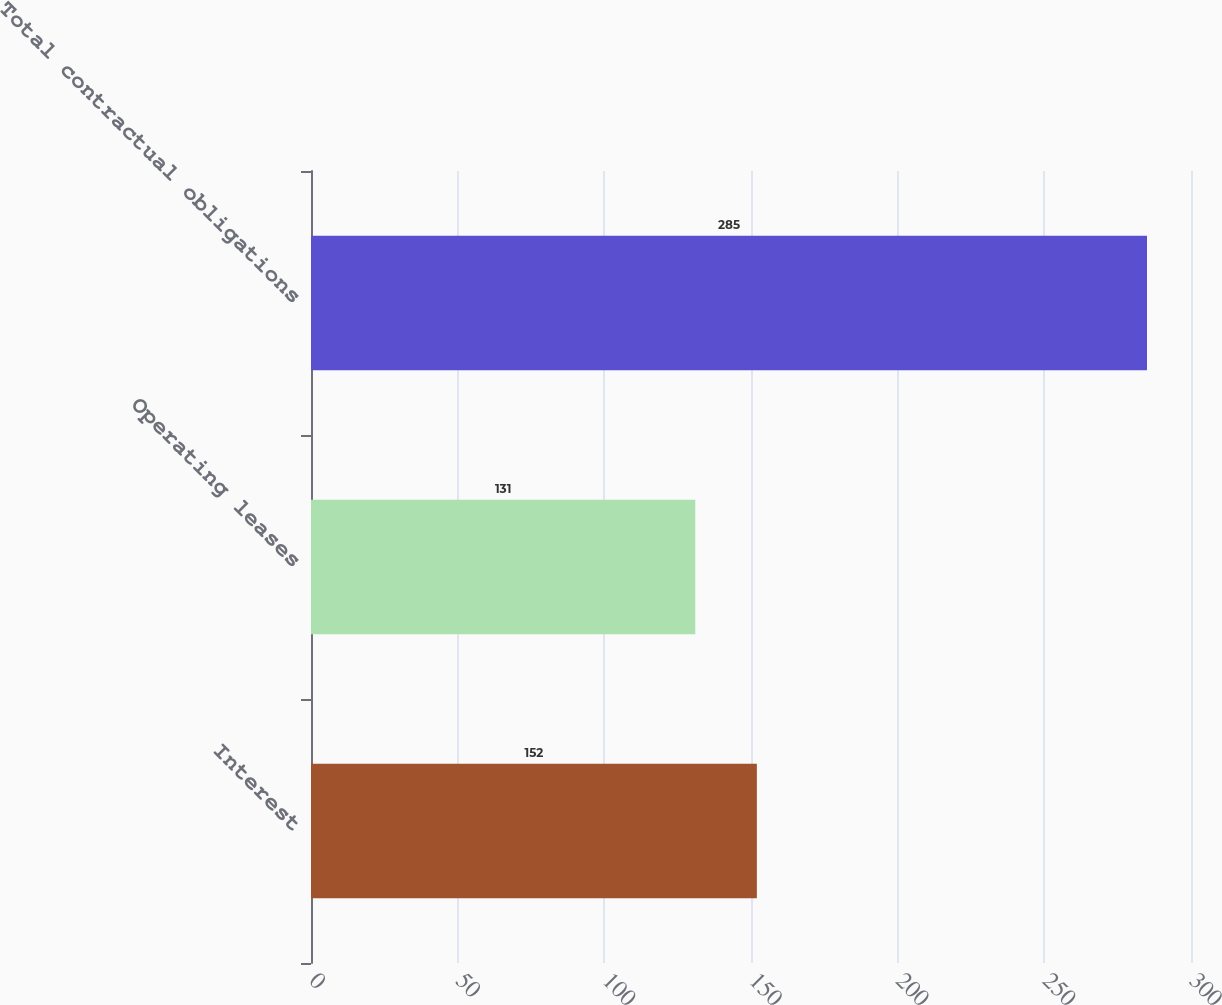<chart> <loc_0><loc_0><loc_500><loc_500><bar_chart><fcel>Interest<fcel>Operating leases<fcel>Total contractual obligations<nl><fcel>152<fcel>131<fcel>285<nl></chart> 